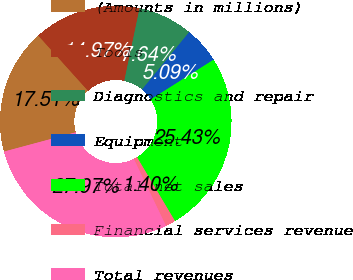Convert chart to OTSL. <chart><loc_0><loc_0><loc_500><loc_500><pie_chart><fcel>(Amounts in millions)<fcel>Tools<fcel>Diagnostics and repair<fcel>Equipment<fcel>Total net sales<fcel>Financial services revenue<fcel>Total revenues<nl><fcel>17.51%<fcel>14.97%<fcel>7.64%<fcel>5.09%<fcel>25.43%<fcel>1.4%<fcel>27.97%<nl></chart> 